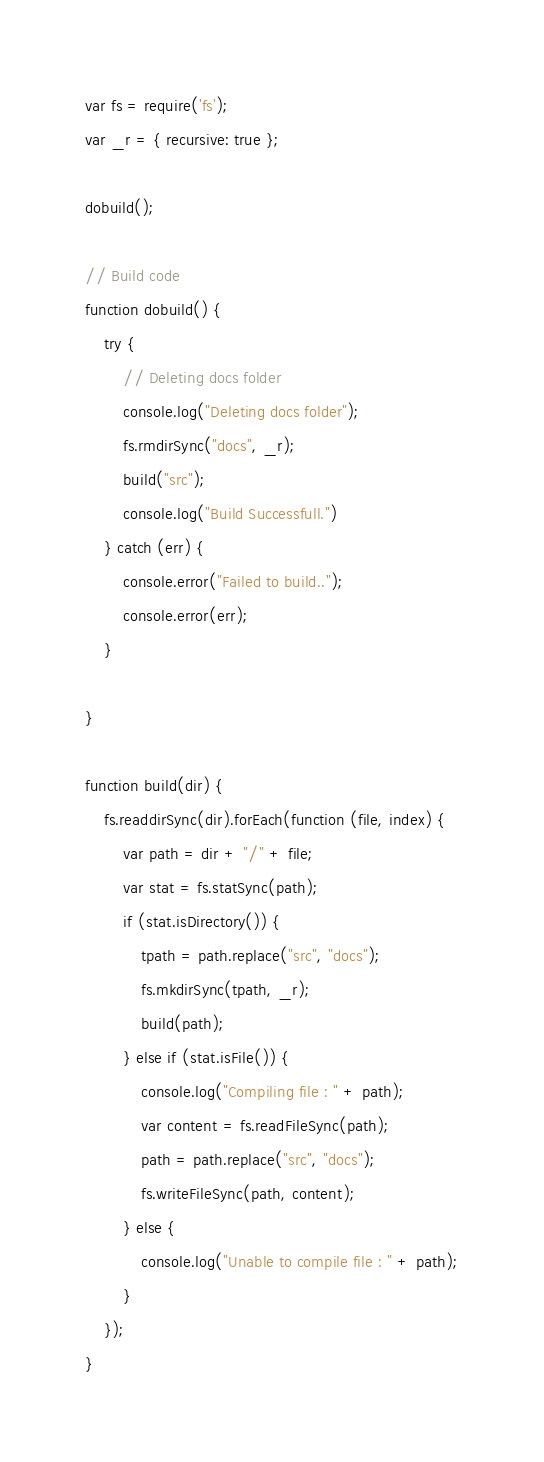Convert code to text. <code><loc_0><loc_0><loc_500><loc_500><_JavaScript_>var fs = require('fs');
var _r = { recursive: true };

dobuild();

// Build code
function dobuild() {
    try {
        // Deleting docs folder
        console.log("Deleting docs folder");
        fs.rmdirSync("docs", _r);
        build("src");
        console.log("Build Successfull.")
    } catch (err) {
        console.error("Failed to build..");
        console.error(err);
    }

}

function build(dir) {
    fs.readdirSync(dir).forEach(function (file, index) {
        var path = dir + "/" + file;
        var stat = fs.statSync(path);
        if (stat.isDirectory()) {
            tpath = path.replace("src", "docs");
            fs.mkdirSync(tpath, _r);
            build(path);
        } else if (stat.isFile()) {
            console.log("Compiling file : " + path);
            var content = fs.readFileSync(path);
            path = path.replace("src", "docs");
            fs.writeFileSync(path, content);
        } else {
            console.log("Unable to compile file : " + path);
        }
    });
}</code> 